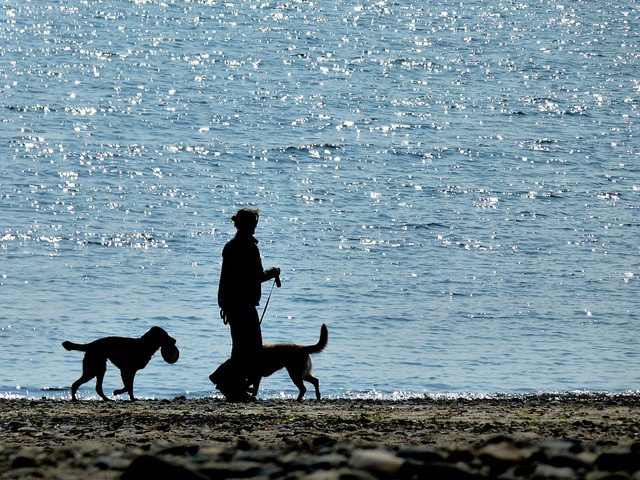<image>What animals are swimming? There are no animals swimming in the image. However, if there are animals, they might be dogs. What animals are swimming? Some of the dogs are swimming. 